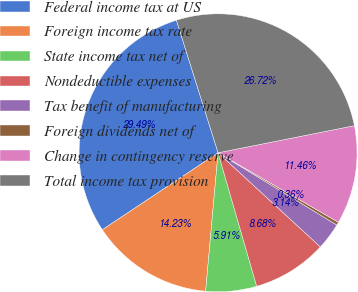Convert chart to OTSL. <chart><loc_0><loc_0><loc_500><loc_500><pie_chart><fcel>Federal income tax at US<fcel>Foreign income tax rate<fcel>State income tax net of<fcel>Nondeductible expenses<fcel>Tax benefit of manufacturing<fcel>Foreign dividends net of<fcel>Change in contingency reserve<fcel>Total income tax provision<nl><fcel>29.49%<fcel>14.23%<fcel>5.91%<fcel>8.68%<fcel>3.14%<fcel>0.36%<fcel>11.46%<fcel>26.72%<nl></chart> 